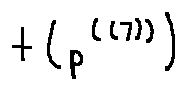Convert formula to latex. <formula><loc_0><loc_0><loc_500><loc_500>t ( p ^ { ( ( 7 ) ) } )</formula> 